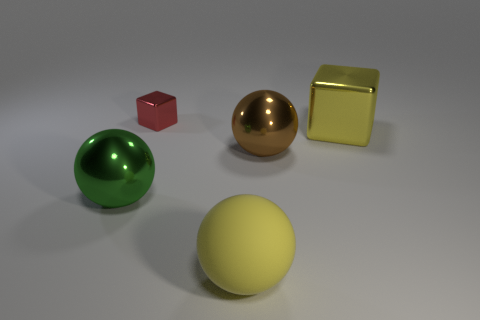Add 1 yellow metallic blocks. How many objects exist? 6 Subtract all cubes. How many objects are left? 3 Subtract 0 gray cylinders. How many objects are left? 5 Subtract all big shiny cubes. Subtract all shiny spheres. How many objects are left? 2 Add 3 green metallic objects. How many green metallic objects are left? 4 Add 2 big green things. How many big green things exist? 3 